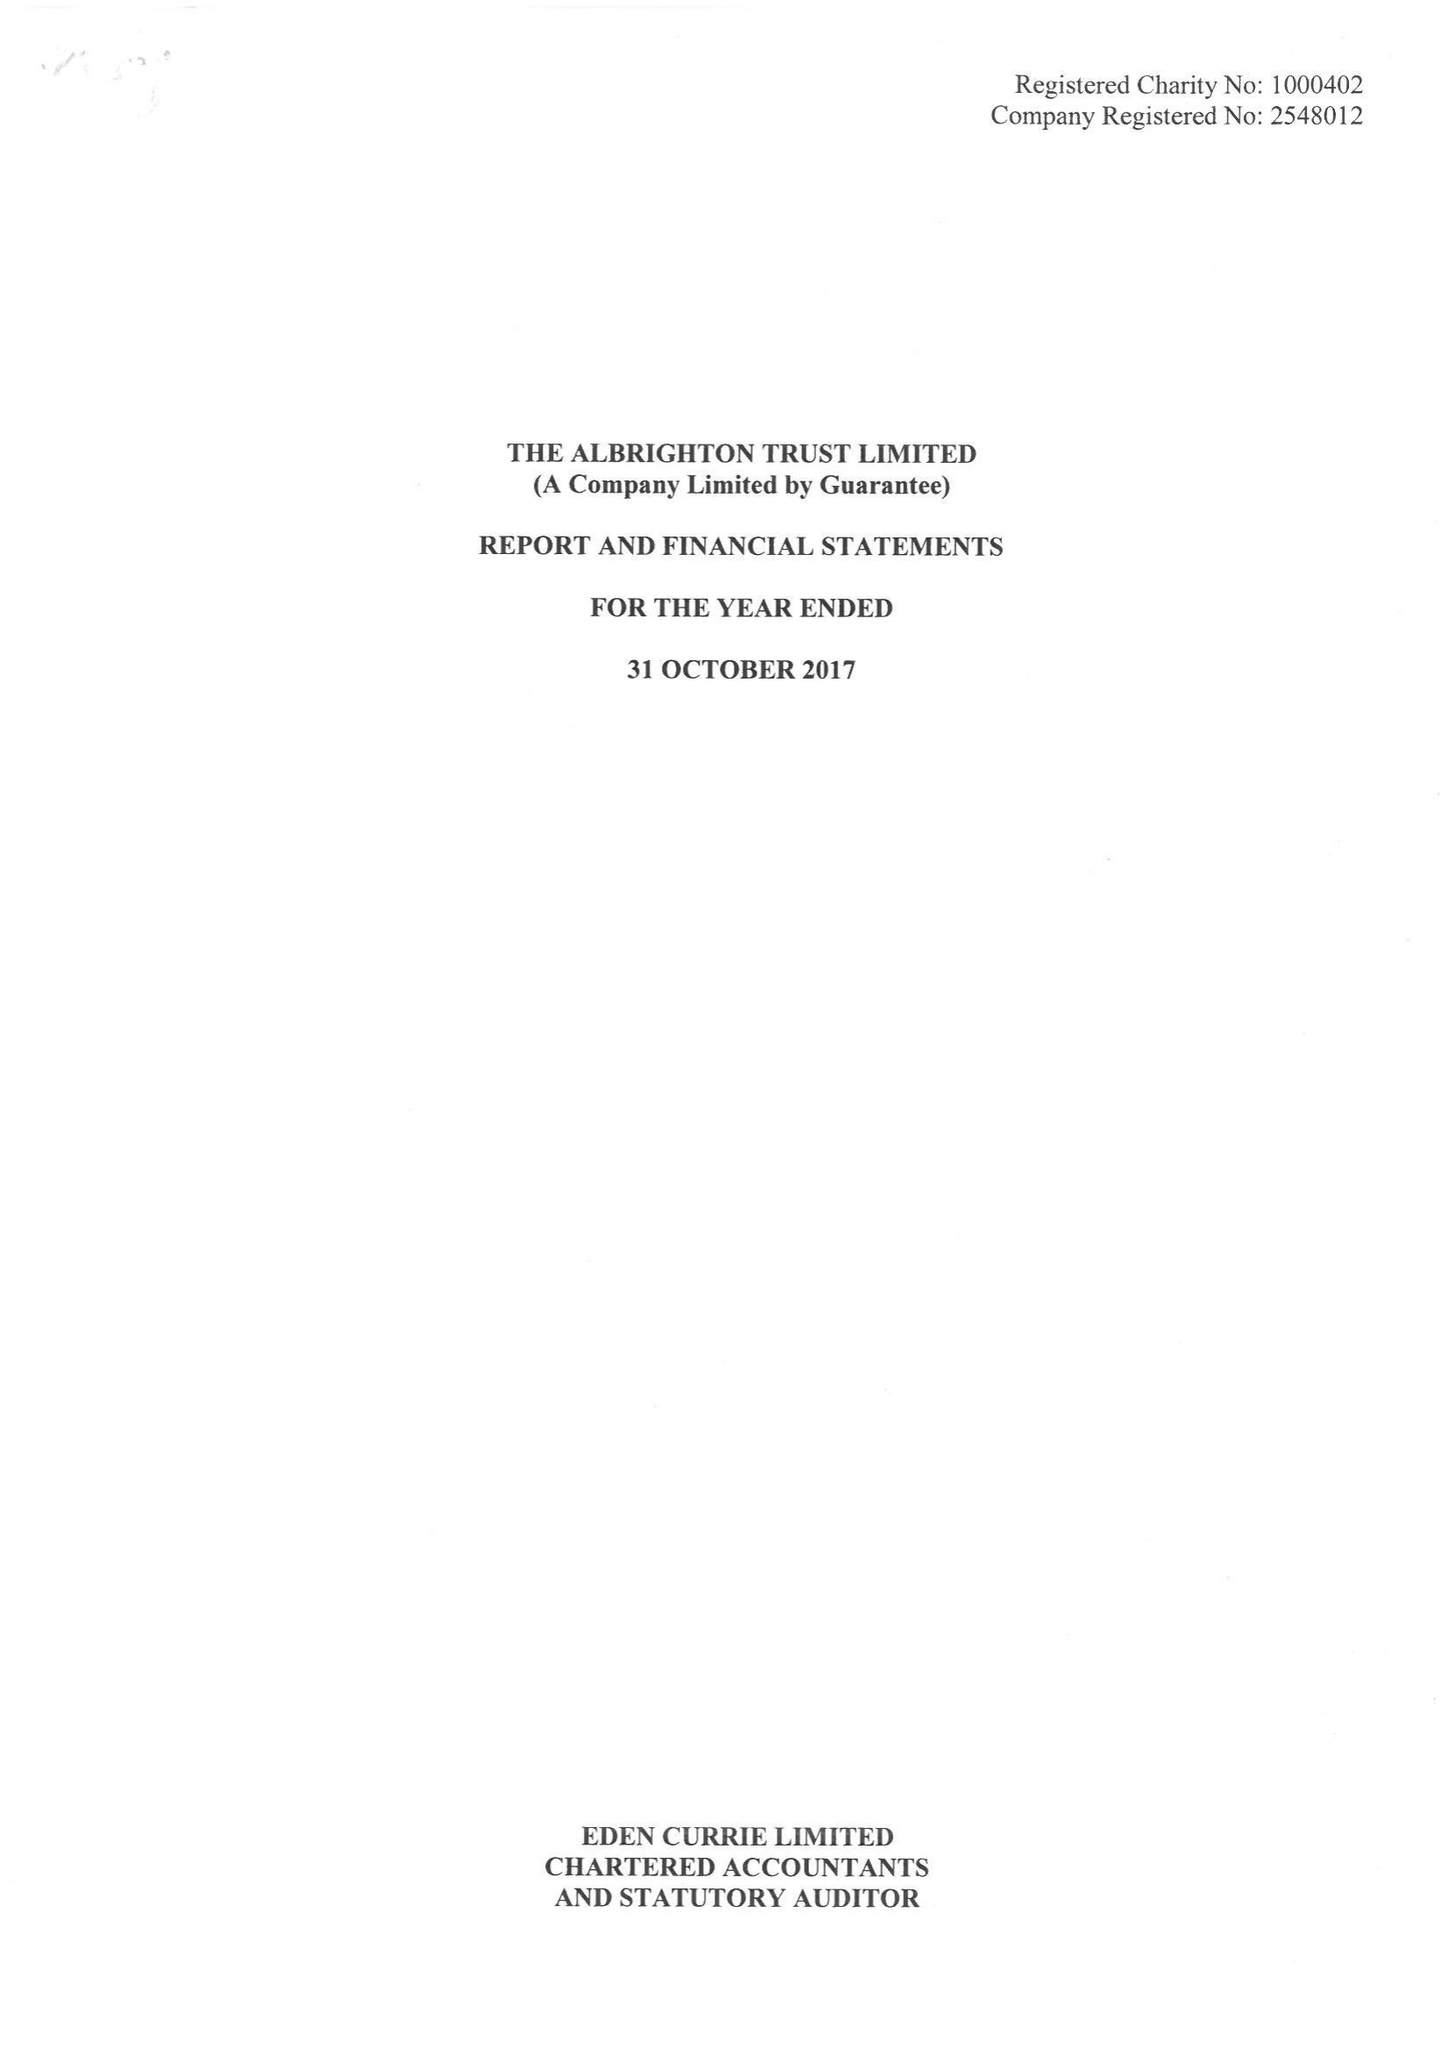What is the value for the charity_number?
Answer the question using a single word or phrase. 1000402 